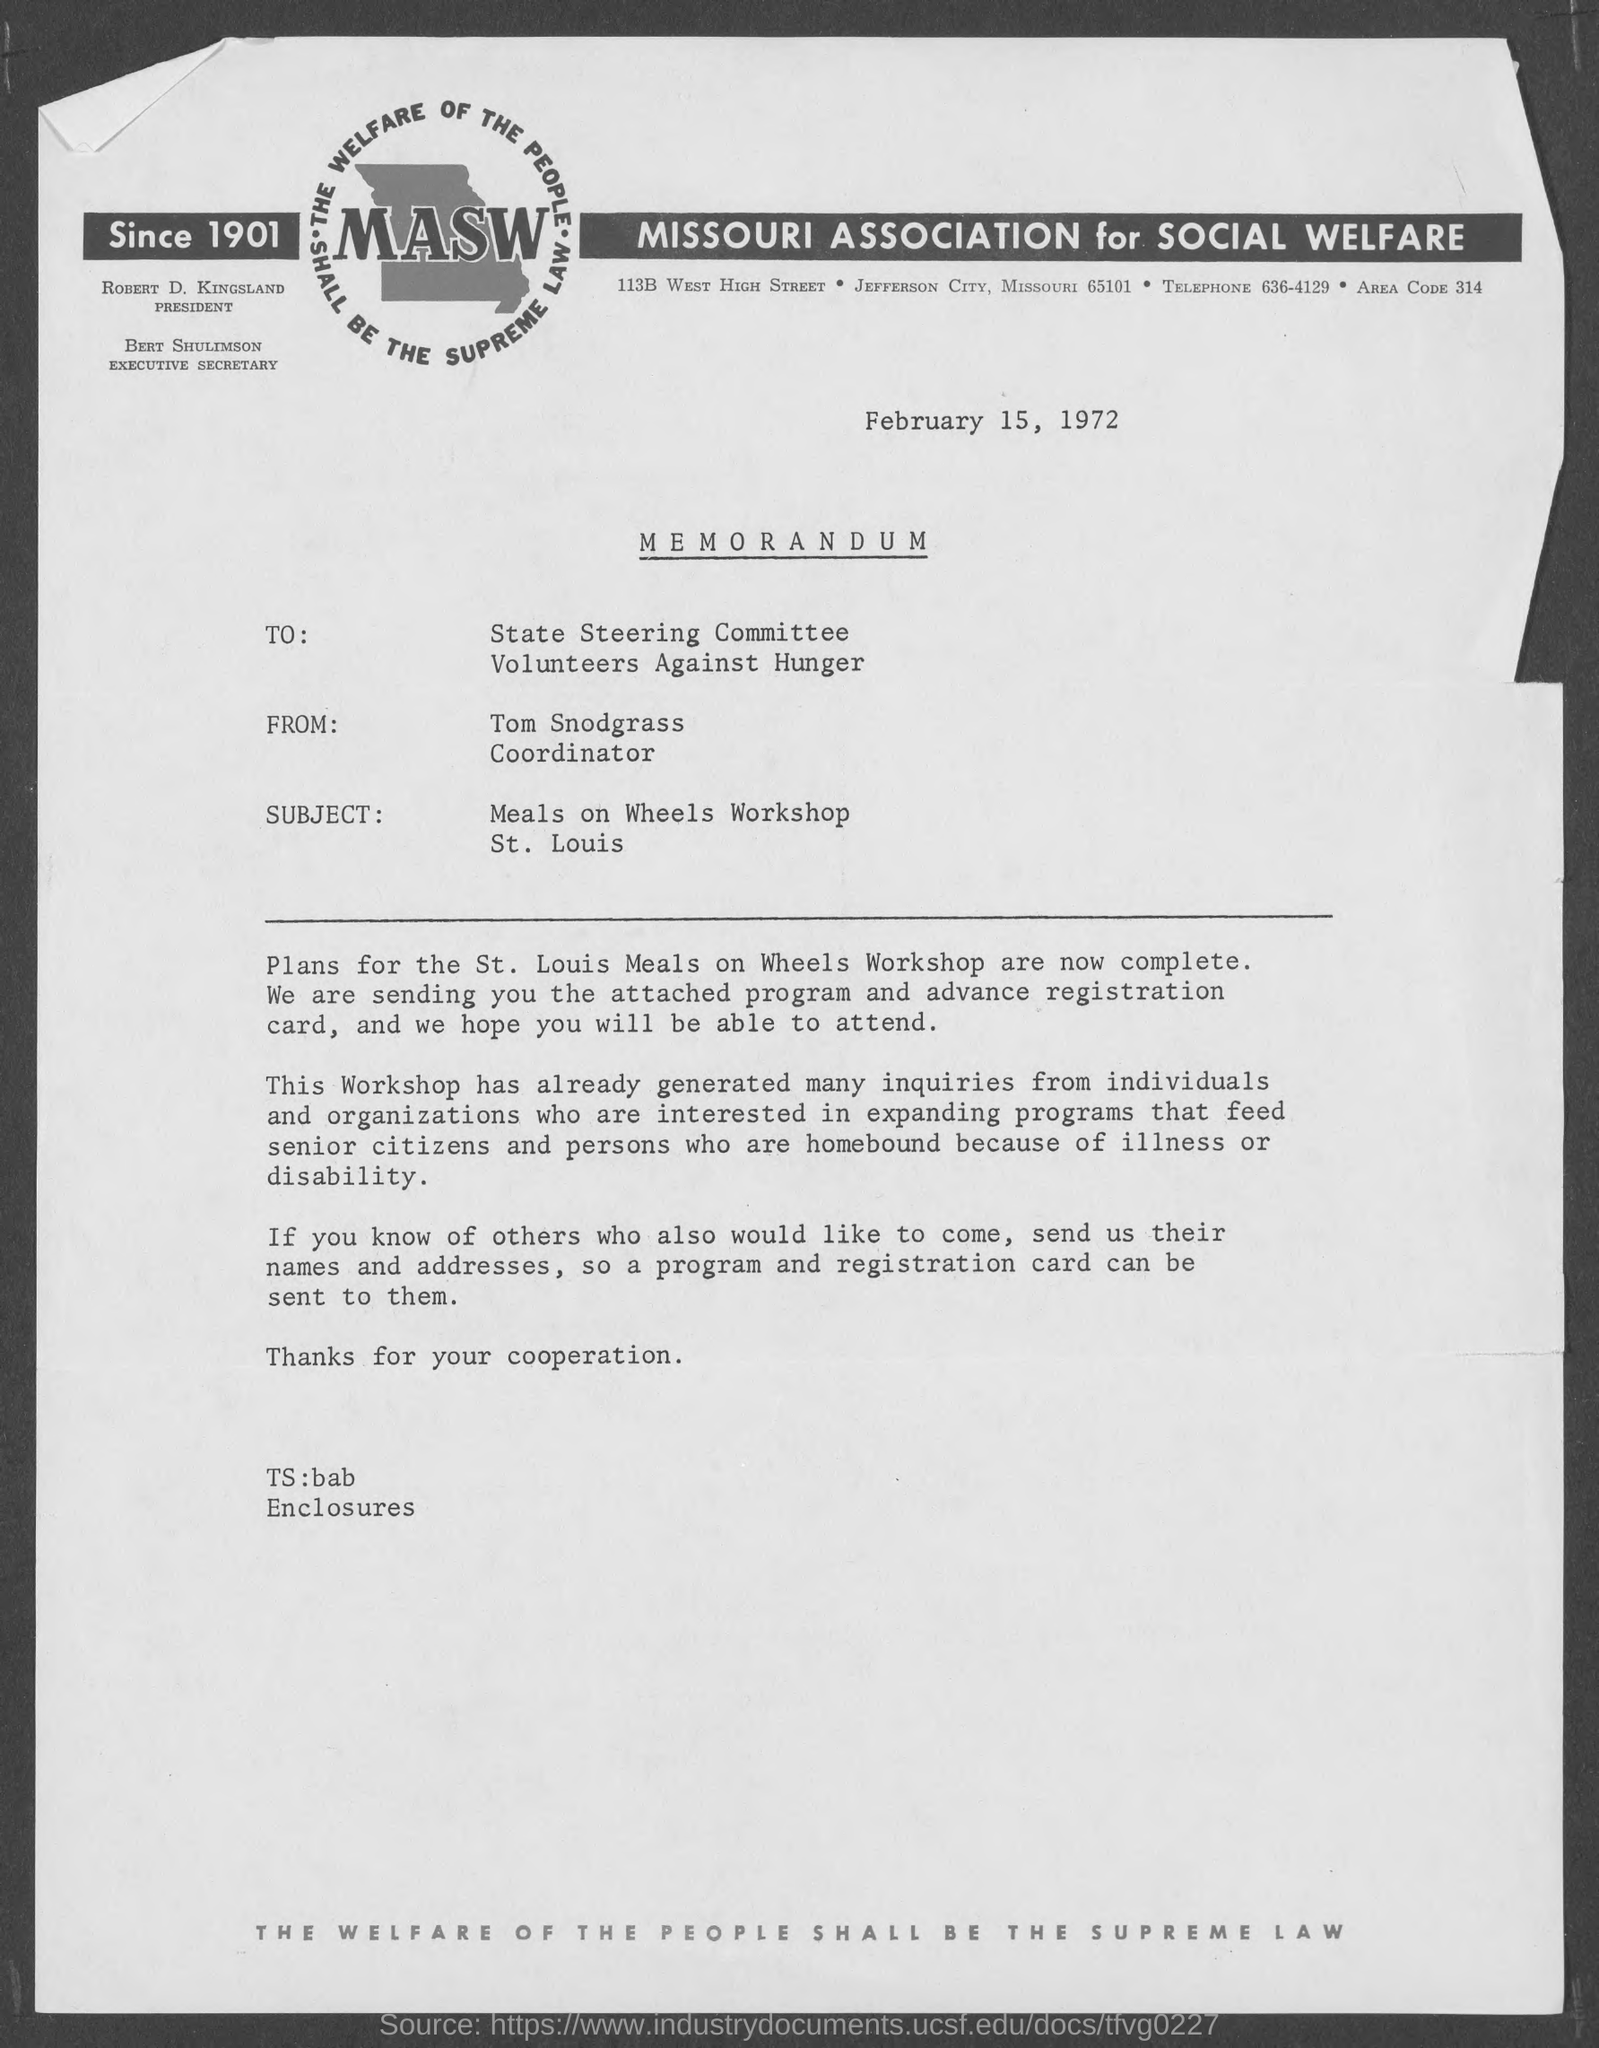What is the date mentioned in the memorandum?
Provide a short and direct response. February 15, 1972. What is the fullform of MASW?
Offer a terse response. MISSOURI ASSOCIATION for SOCIAL WELFARE. What is the subject of this memorandum?
Provide a short and direct response. Meals on Wheels Workshop St. Louis. Who is the sender of this memorandum?
Your response must be concise. Tom Snodgrass. What is the designation of Tom Snodgrass?
Make the answer very short. Coordinator. Who is the President of MASW?
Offer a very short reply. ROBERT D. KINGSLAND. 